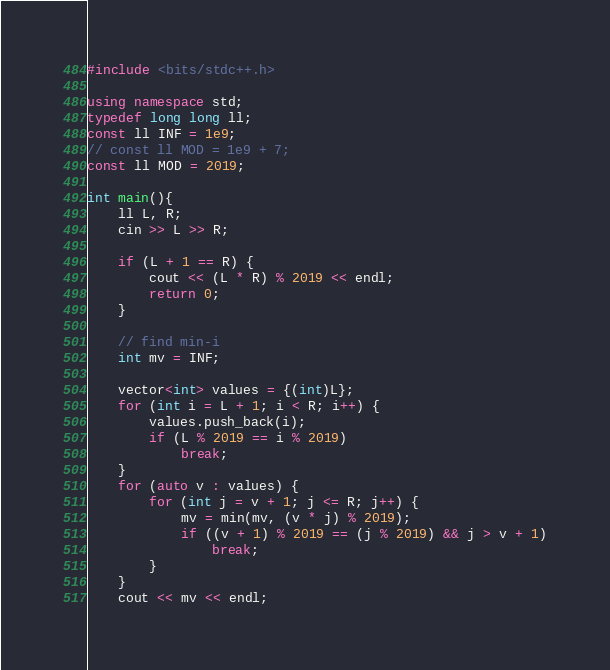Convert code to text. <code><loc_0><loc_0><loc_500><loc_500><_C++_>#include <bits/stdc++.h>

using namespace std;
typedef long long ll;
const ll INF = 1e9;
// const ll MOD = 1e9 + 7;
const ll MOD = 2019;

int main(){
    ll L, R;
    cin >> L >> R;

    if (L + 1 == R) {
        cout << (L * R) % 2019 << endl;
        return 0;
    }

    // find min-i
    int mv = INF;

    vector<int> values = {(int)L};
    for (int i = L + 1; i < R; i++) {
        values.push_back(i);
        if (L % 2019 == i % 2019)
            break;
    }
    for (auto v : values) {
        for (int j = v + 1; j <= R; j++) {
            mv = min(mv, (v * j) % 2019);
            if ((v + 1) % 2019 == (j % 2019) && j > v + 1)
                break;
        }
    }
    cout << mv << endl;</code> 